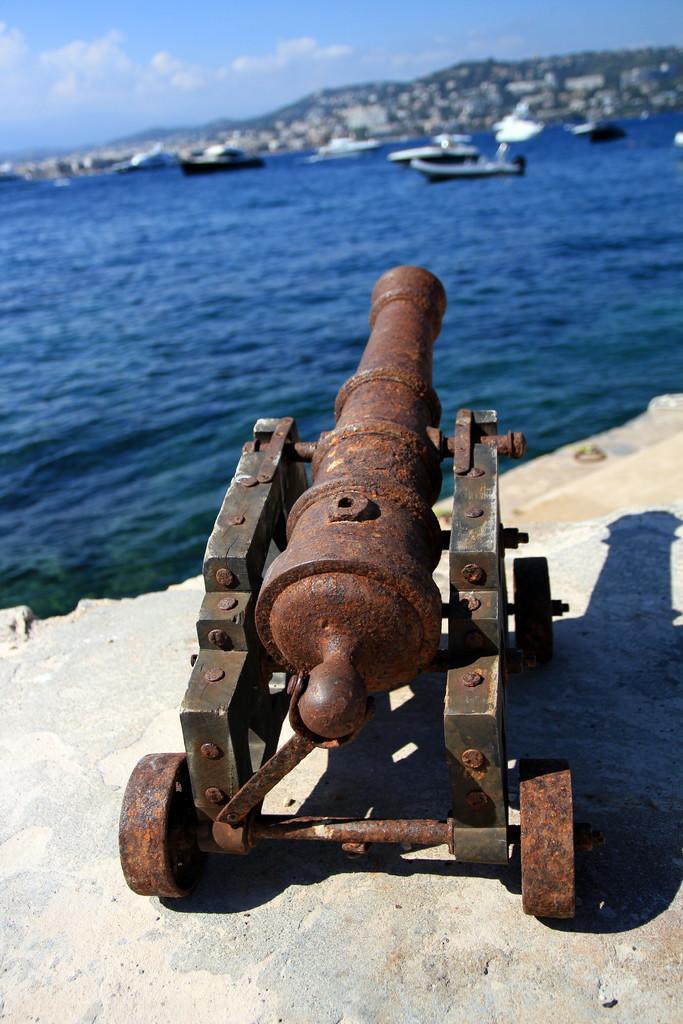Could you give a brief overview of what you see in this image? In this picture, we can see a cannon on the ground, we can see water, boats, mountains, and the sky with clouds. 